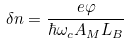<formula> <loc_0><loc_0><loc_500><loc_500>\delta n = { \frac { e \varphi } { \hbar { \omega } _ { c } A _ { M } L _ { B } } }</formula> 